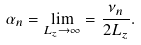<formula> <loc_0><loc_0><loc_500><loc_500>\alpha _ { n } = \lim _ { L _ { z } \rightarrow \infty } = \frac { \nu _ { n } } { 2 L _ { z } } .</formula> 